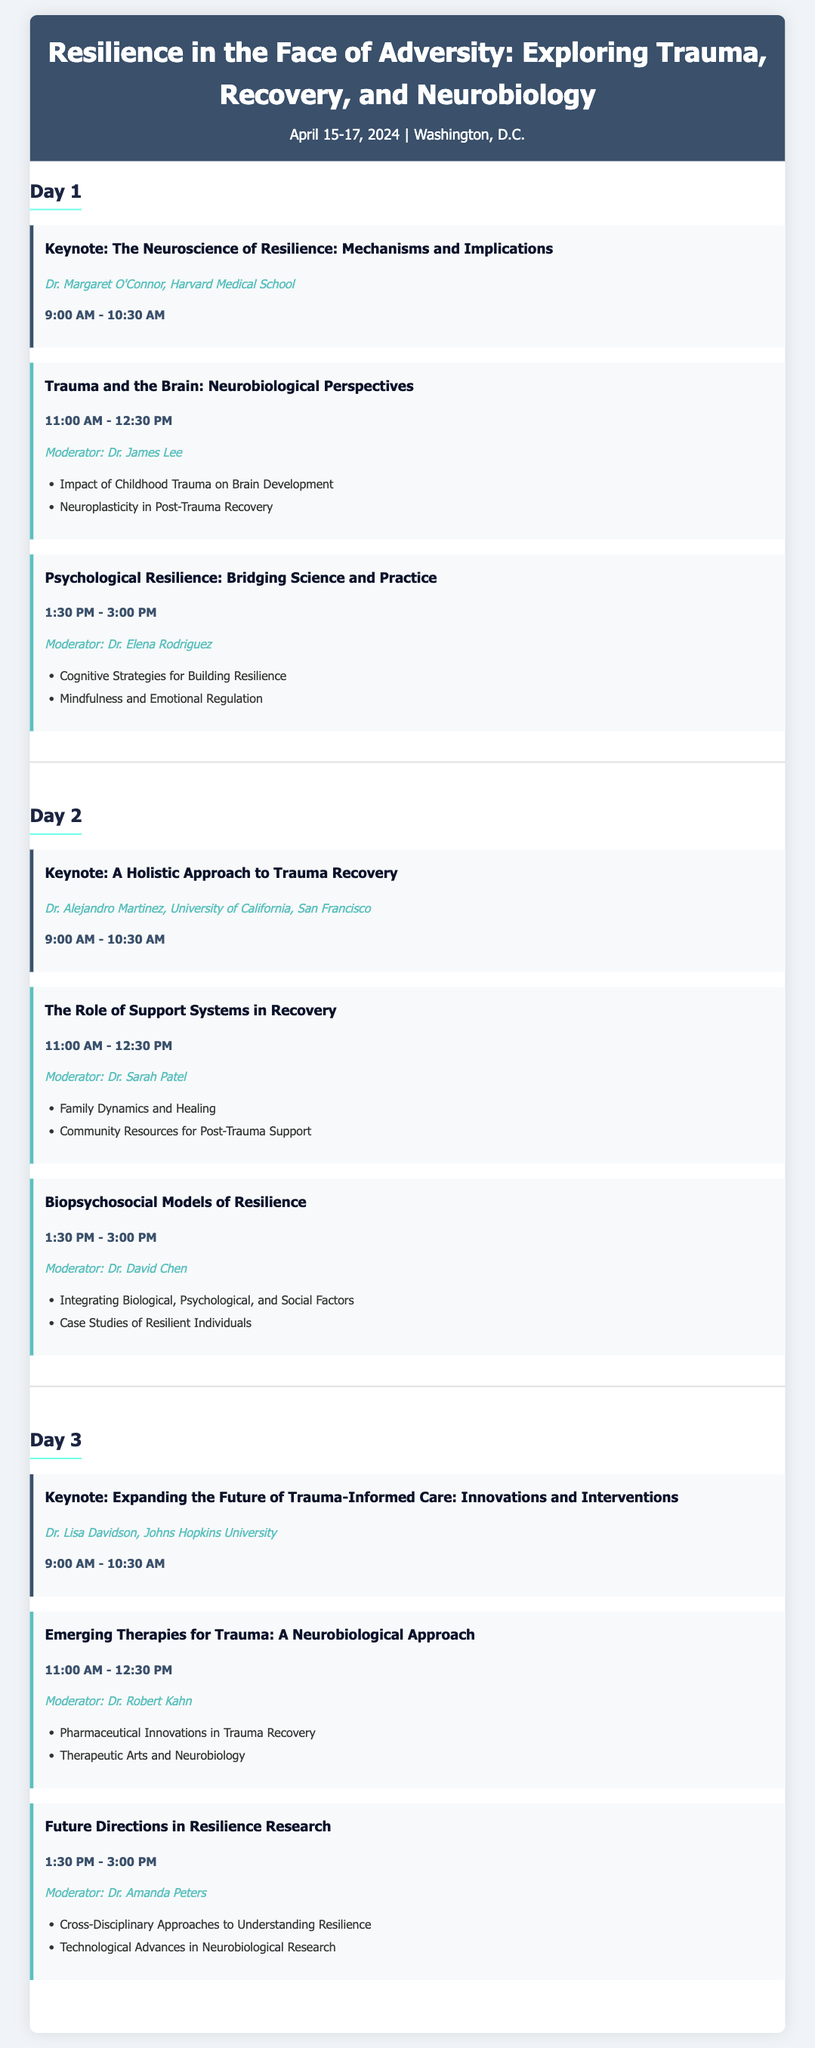What is the main theme of the conference? The theme is stated in the conference title, which focuses on trauma, recovery, and neurobiology.
Answer: Resilience in the Face of Adversity: Exploring Trauma, Recovery, and Neurobiology When is the conference scheduled to take place? The dates of the conference are mentioned in the conference information section.
Answer: April 15-17, 2024 Who is the keynote speaker on Day 1? The keynote speaker for Day 1 is identified in the Day 1 section under the keynote.
Answer: Dr. Margaret O'Connor What is the duration of each keynote presentation? The time for each keynote is consistently listed, indicating their length.
Answer: 1 hour 30 minutes Which session on Day 2 has the topic "Biopsychosocial Models of Resilience"? The session title is specified in the Day 2 section and can be found there.
Answer: Session at 1:30 PM - 3:00 PM What is the focus of the session titled "Emerging Therapies for Trauma"? The main theme of this session can be inferred from the title itself.
Answer: A Neurobiological Approach Who is moderating the session on "The Role of Support Systems in Recovery"? The moderator for this session is provided in the details of that session.
Answer: Dr. Sarah Patel Which Day features a keynote titled "Expanding the Future of Trauma-Informed Care"? The day is indicated in the section for that specific keynote.
Answer: Day 3 How many sessions are scheduled for Day 2? The number of sessions is counted as listed in the Day 2 section.
Answer: Two sessions 